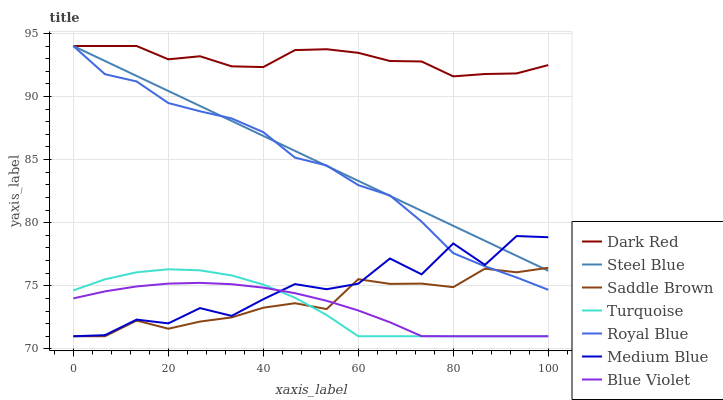Does Blue Violet have the minimum area under the curve?
Answer yes or no. Yes. Does Dark Red have the maximum area under the curve?
Answer yes or no. Yes. Does Medium Blue have the minimum area under the curve?
Answer yes or no. No. Does Medium Blue have the maximum area under the curve?
Answer yes or no. No. Is Steel Blue the smoothest?
Answer yes or no. Yes. Is Medium Blue the roughest?
Answer yes or no. Yes. Is Dark Red the smoothest?
Answer yes or no. No. Is Dark Red the roughest?
Answer yes or no. No. Does Turquoise have the lowest value?
Answer yes or no. Yes. Does Dark Red have the lowest value?
Answer yes or no. No. Does Royal Blue have the highest value?
Answer yes or no. Yes. Does Medium Blue have the highest value?
Answer yes or no. No. Is Medium Blue less than Dark Red?
Answer yes or no. Yes. Is Steel Blue greater than Blue Violet?
Answer yes or no. Yes. Does Medium Blue intersect Saddle Brown?
Answer yes or no. Yes. Is Medium Blue less than Saddle Brown?
Answer yes or no. No. Is Medium Blue greater than Saddle Brown?
Answer yes or no. No. Does Medium Blue intersect Dark Red?
Answer yes or no. No. 